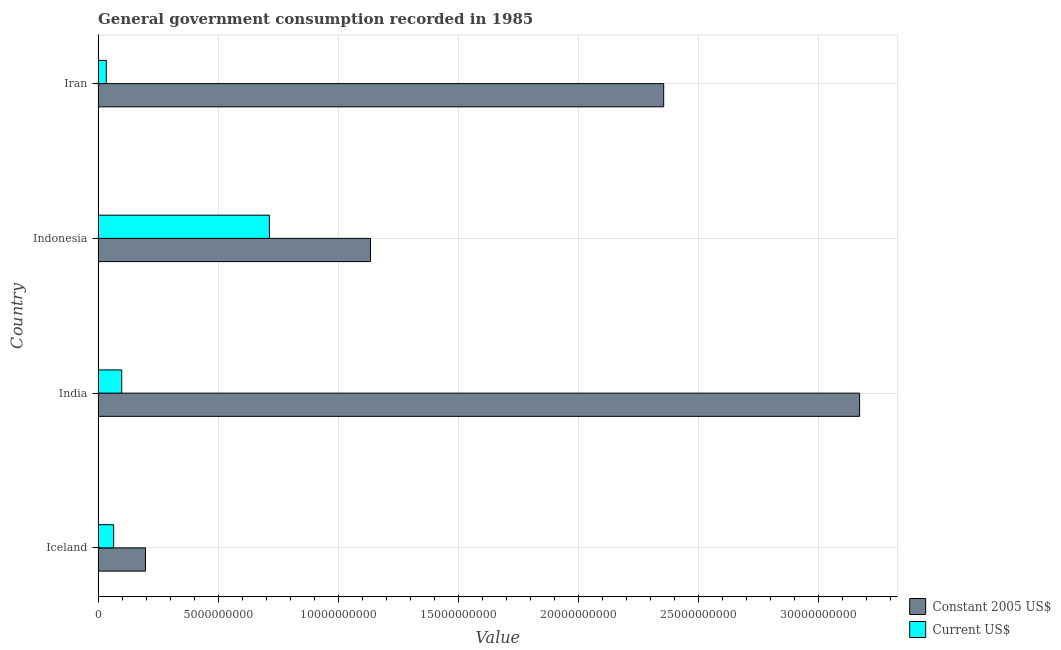How many different coloured bars are there?
Offer a terse response. 2. Are the number of bars per tick equal to the number of legend labels?
Give a very brief answer. Yes. What is the label of the 4th group of bars from the top?
Your answer should be very brief. Iceland. What is the value consumed in constant 2005 us$ in India?
Offer a very short reply. 3.17e+1. Across all countries, what is the maximum value consumed in constant 2005 us$?
Offer a terse response. 3.17e+1. Across all countries, what is the minimum value consumed in constant 2005 us$?
Keep it short and to the point. 1.97e+09. In which country was the value consumed in constant 2005 us$ maximum?
Your answer should be very brief. India. In which country was the value consumed in constant 2005 us$ minimum?
Provide a short and direct response. Iceland. What is the total value consumed in current us$ in the graph?
Keep it short and to the point. 9.10e+09. What is the difference between the value consumed in constant 2005 us$ in Indonesia and that in Iran?
Give a very brief answer. -1.22e+1. What is the difference between the value consumed in constant 2005 us$ in Indonesia and the value consumed in current us$ in Iceland?
Your answer should be very brief. 1.07e+1. What is the average value consumed in current us$ per country?
Keep it short and to the point. 2.28e+09. What is the difference between the value consumed in constant 2005 us$ and value consumed in current us$ in Iceland?
Keep it short and to the point. 1.33e+09. What is the ratio of the value consumed in constant 2005 us$ in India to that in Iran?
Give a very brief answer. 1.35. Is the value consumed in current us$ in Iceland less than that in Iran?
Keep it short and to the point. No. Is the difference between the value consumed in constant 2005 us$ in Indonesia and Iran greater than the difference between the value consumed in current us$ in Indonesia and Iran?
Provide a short and direct response. No. What is the difference between the highest and the second highest value consumed in current us$?
Provide a short and direct response. 6.15e+09. What is the difference between the highest and the lowest value consumed in constant 2005 us$?
Provide a short and direct response. 2.97e+1. Is the sum of the value consumed in current us$ in Iceland and Indonesia greater than the maximum value consumed in constant 2005 us$ across all countries?
Give a very brief answer. No. What does the 2nd bar from the top in India represents?
Ensure brevity in your answer.  Constant 2005 US$. What does the 2nd bar from the bottom in Indonesia represents?
Offer a very short reply. Current US$. Are the values on the major ticks of X-axis written in scientific E-notation?
Give a very brief answer. No. Does the graph contain any zero values?
Give a very brief answer. No. Where does the legend appear in the graph?
Give a very brief answer. Bottom right. How many legend labels are there?
Offer a terse response. 2. What is the title of the graph?
Offer a very short reply. General government consumption recorded in 1985. What is the label or title of the X-axis?
Your answer should be compact. Value. What is the Value of Constant 2005 US$ in Iceland?
Make the answer very short. 1.97e+09. What is the Value of Current US$ in Iceland?
Your answer should be compact. 6.47e+08. What is the Value of Constant 2005 US$ in India?
Keep it short and to the point. 3.17e+1. What is the Value of Current US$ in India?
Make the answer very short. 9.83e+08. What is the Value of Constant 2005 US$ in Indonesia?
Provide a succinct answer. 1.13e+1. What is the Value of Current US$ in Indonesia?
Give a very brief answer. 7.13e+09. What is the Value of Constant 2005 US$ in Iran?
Offer a very short reply. 2.35e+1. What is the Value in Current US$ in Iran?
Give a very brief answer. 3.42e+08. Across all countries, what is the maximum Value in Constant 2005 US$?
Offer a terse response. 3.17e+1. Across all countries, what is the maximum Value in Current US$?
Make the answer very short. 7.13e+09. Across all countries, what is the minimum Value of Constant 2005 US$?
Provide a succinct answer. 1.97e+09. Across all countries, what is the minimum Value of Current US$?
Your answer should be compact. 3.42e+08. What is the total Value of Constant 2005 US$ in the graph?
Your answer should be very brief. 6.86e+1. What is the total Value of Current US$ in the graph?
Your response must be concise. 9.10e+09. What is the difference between the Value in Constant 2005 US$ in Iceland and that in India?
Ensure brevity in your answer.  -2.97e+1. What is the difference between the Value of Current US$ in Iceland and that in India?
Make the answer very short. -3.36e+08. What is the difference between the Value of Constant 2005 US$ in Iceland and that in Indonesia?
Make the answer very short. -9.37e+09. What is the difference between the Value in Current US$ in Iceland and that in Indonesia?
Offer a terse response. -6.49e+09. What is the difference between the Value of Constant 2005 US$ in Iceland and that in Iran?
Make the answer very short. -2.16e+1. What is the difference between the Value in Current US$ in Iceland and that in Iran?
Make the answer very short. 3.05e+08. What is the difference between the Value of Constant 2005 US$ in India and that in Indonesia?
Keep it short and to the point. 2.04e+1. What is the difference between the Value of Current US$ in India and that in Indonesia?
Give a very brief answer. -6.15e+09. What is the difference between the Value in Constant 2005 US$ in India and that in Iran?
Provide a short and direct response. 8.16e+09. What is the difference between the Value in Current US$ in India and that in Iran?
Ensure brevity in your answer.  6.41e+08. What is the difference between the Value of Constant 2005 US$ in Indonesia and that in Iran?
Provide a short and direct response. -1.22e+1. What is the difference between the Value of Current US$ in Indonesia and that in Iran?
Your answer should be compact. 6.79e+09. What is the difference between the Value in Constant 2005 US$ in Iceland and the Value in Current US$ in India?
Ensure brevity in your answer.  9.89e+08. What is the difference between the Value of Constant 2005 US$ in Iceland and the Value of Current US$ in Indonesia?
Give a very brief answer. -5.16e+09. What is the difference between the Value of Constant 2005 US$ in Iceland and the Value of Current US$ in Iran?
Make the answer very short. 1.63e+09. What is the difference between the Value in Constant 2005 US$ in India and the Value in Current US$ in Indonesia?
Make the answer very short. 2.46e+1. What is the difference between the Value in Constant 2005 US$ in India and the Value in Current US$ in Iran?
Keep it short and to the point. 3.14e+1. What is the difference between the Value of Constant 2005 US$ in Indonesia and the Value of Current US$ in Iran?
Provide a succinct answer. 1.10e+1. What is the average Value of Constant 2005 US$ per country?
Keep it short and to the point. 1.71e+1. What is the average Value in Current US$ per country?
Provide a short and direct response. 2.28e+09. What is the difference between the Value in Constant 2005 US$ and Value in Current US$ in Iceland?
Your answer should be very brief. 1.33e+09. What is the difference between the Value in Constant 2005 US$ and Value in Current US$ in India?
Your answer should be compact. 3.07e+1. What is the difference between the Value in Constant 2005 US$ and Value in Current US$ in Indonesia?
Your answer should be very brief. 4.21e+09. What is the difference between the Value in Constant 2005 US$ and Value in Current US$ in Iran?
Your answer should be compact. 2.32e+1. What is the ratio of the Value of Constant 2005 US$ in Iceland to that in India?
Make the answer very short. 0.06. What is the ratio of the Value in Current US$ in Iceland to that in India?
Give a very brief answer. 0.66. What is the ratio of the Value in Constant 2005 US$ in Iceland to that in Indonesia?
Make the answer very short. 0.17. What is the ratio of the Value in Current US$ in Iceland to that in Indonesia?
Ensure brevity in your answer.  0.09. What is the ratio of the Value in Constant 2005 US$ in Iceland to that in Iran?
Your answer should be compact. 0.08. What is the ratio of the Value of Current US$ in Iceland to that in Iran?
Ensure brevity in your answer.  1.89. What is the ratio of the Value in Constant 2005 US$ in India to that in Indonesia?
Offer a very short reply. 2.8. What is the ratio of the Value in Current US$ in India to that in Indonesia?
Provide a succinct answer. 0.14. What is the ratio of the Value of Constant 2005 US$ in India to that in Iran?
Keep it short and to the point. 1.35. What is the ratio of the Value of Current US$ in India to that in Iran?
Offer a very short reply. 2.88. What is the ratio of the Value in Constant 2005 US$ in Indonesia to that in Iran?
Make the answer very short. 0.48. What is the ratio of the Value of Current US$ in Indonesia to that in Iran?
Your response must be concise. 20.86. What is the difference between the highest and the second highest Value of Constant 2005 US$?
Ensure brevity in your answer.  8.16e+09. What is the difference between the highest and the second highest Value of Current US$?
Your answer should be very brief. 6.15e+09. What is the difference between the highest and the lowest Value of Constant 2005 US$?
Make the answer very short. 2.97e+1. What is the difference between the highest and the lowest Value of Current US$?
Provide a succinct answer. 6.79e+09. 